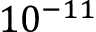Convert formula to latex. <formula><loc_0><loc_0><loc_500><loc_500>1 0 ^ { - 1 1 }</formula> 